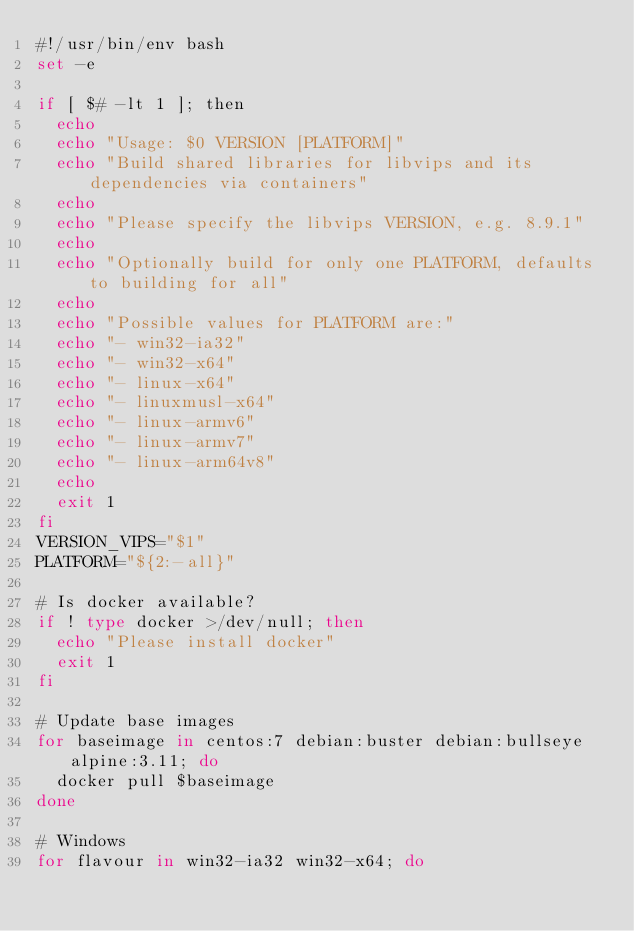<code> <loc_0><loc_0><loc_500><loc_500><_Bash_>#!/usr/bin/env bash
set -e

if [ $# -lt 1 ]; then
  echo
  echo "Usage: $0 VERSION [PLATFORM]"
  echo "Build shared libraries for libvips and its dependencies via containers"
  echo
  echo "Please specify the libvips VERSION, e.g. 8.9.1"
  echo
  echo "Optionally build for only one PLATFORM, defaults to building for all"
  echo
  echo "Possible values for PLATFORM are:"
  echo "- win32-ia32"
  echo "- win32-x64"
  echo "- linux-x64"
  echo "- linuxmusl-x64"
  echo "- linux-armv6"
  echo "- linux-armv7"
  echo "- linux-arm64v8"
  echo
  exit 1
fi
VERSION_VIPS="$1"
PLATFORM="${2:-all}"

# Is docker available?
if ! type docker >/dev/null; then
  echo "Please install docker"
  exit 1
fi

# Update base images
for baseimage in centos:7 debian:buster debian:bullseye alpine:3.11; do
  docker pull $baseimage
done

# Windows
for flavour in win32-ia32 win32-x64; do</code> 